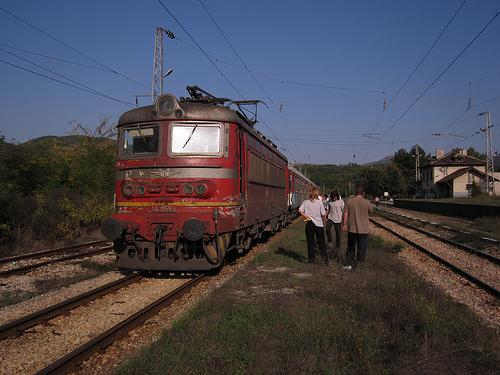Mention one detail of the train that contributes to its overall vintage or weathered appearance. The weathered surface of the train engine contributes to its overall vintage look. Describe the positioning of the train and any other elements in relation to it. The train is in a field, surrounded by grass, plants, and train tracks; people are close to it, and overhead wires run above the train. Buildings are nearby. Explain any other objects or structures visible in the background of the image. There are houses on the left side, a brown and white building next to the tracks, multiple overhead wires above the train and tracks, and a yellow stripe under the train's lights. What details can you identify about the landscape in the image? The landscape includes a green grassy hill, plants, multiple sets of tracks, gravel in front of the train, and a blue sky overhead. Identify the primary object in the image and describe its appearance and surroundings. A long red train with weathered surface and two front windows is parked in a field surrounded by tracks, gravel, plants, and grassy hills. What colors are dominant in the image, and where can they be found? Red is dominant on the train; green is found on the grass, plants, and foliage; blue is present in the sky and white and brown on buildings nearby. What action or activity is taking place involving the people and the train? People are standing close to the train, possibly observing or taking a break from walking near the train rails. Choose one detail from the train's appearance and describe it. The train's windshield is reflecting light and has two windshield wipers on its front. Briefly describe the people near the train and what they are wearing and doing. There are people standing beside the train, with one person in black pants and white shirt walking near the rails and another man in a tan shirt. A woman is wearing white shirt and black pants, and one person is reaching under their shirt hem. List three features that can be observed on the train's front. Two front windows, a windshield reflecting light, and a yellow stripe under the lights are visible on the train's front. 